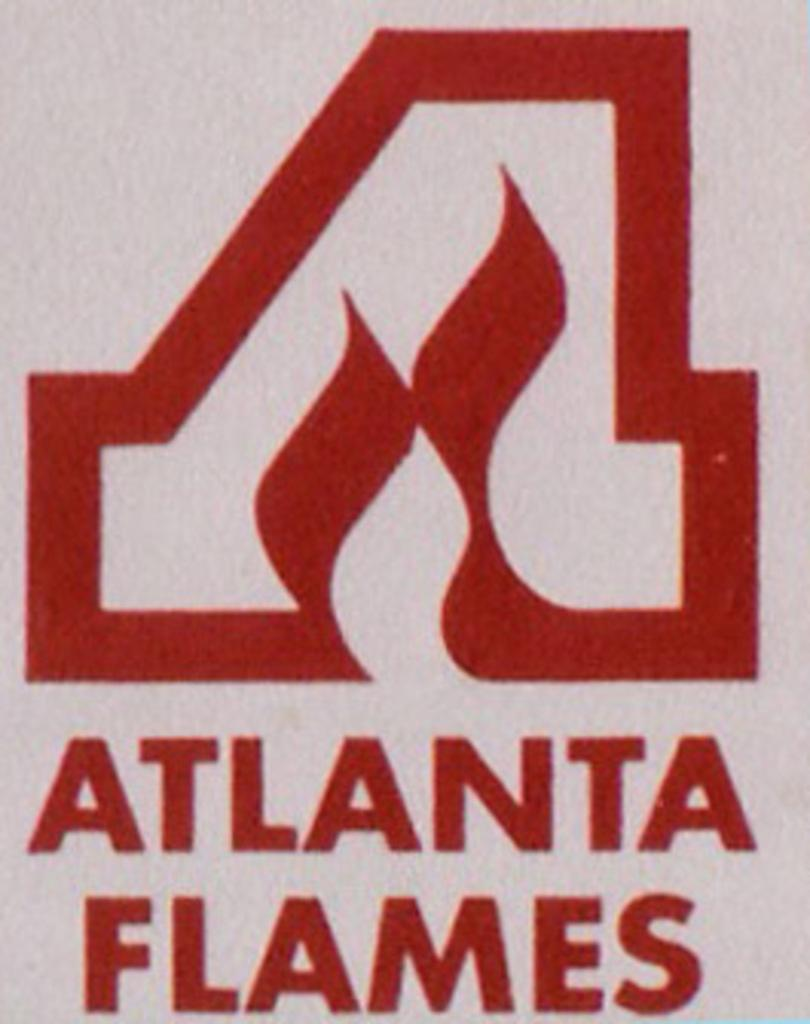<image>
Summarize the visual content of the image. A stylized A appears above the words Atlanta Flames. 